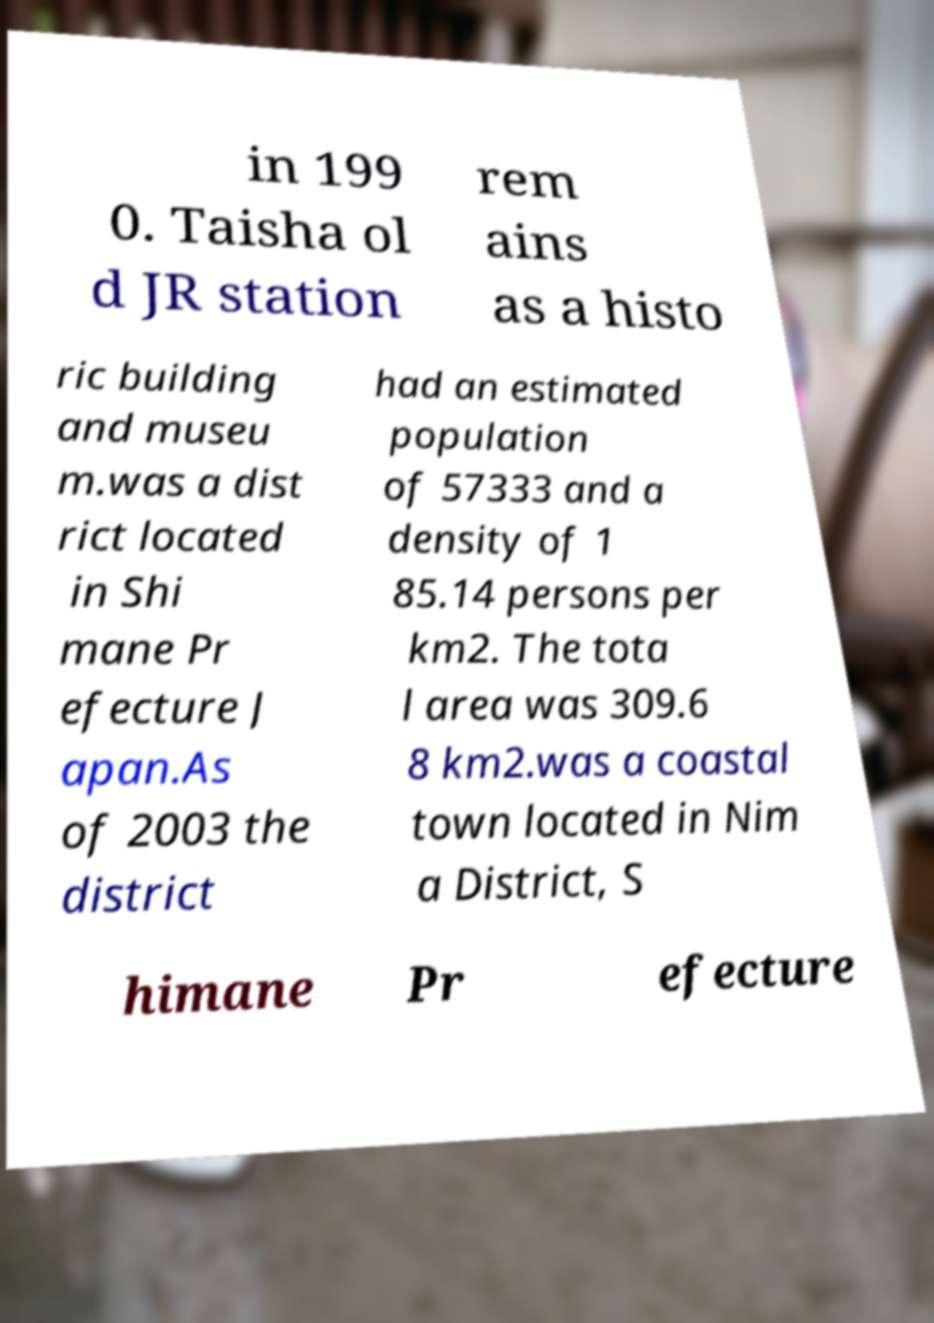What messages or text are displayed in this image? I need them in a readable, typed format. in 199 0. Taisha ol d JR station rem ains as a histo ric building and museu m.was a dist rict located in Shi mane Pr efecture J apan.As of 2003 the district had an estimated population of 57333 and a density of 1 85.14 persons per km2. The tota l area was 309.6 8 km2.was a coastal town located in Nim a District, S himane Pr efecture 